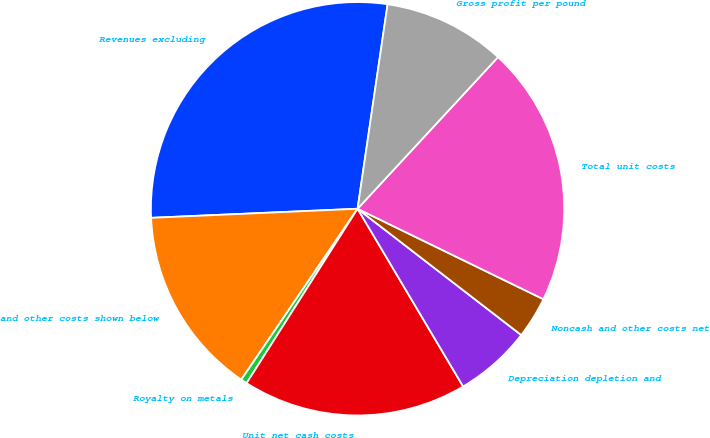<chart> <loc_0><loc_0><loc_500><loc_500><pie_chart><fcel>Revenues excluding<fcel>and other costs shown below<fcel>Royalty on metals<fcel>Unit net cash costs<fcel>Depreciation depletion and<fcel>Noncash and other costs net<fcel>Total unit costs<fcel>Gross profit per pound<nl><fcel>28.02%<fcel>14.79%<fcel>0.49%<fcel>17.55%<fcel>6.01%<fcel>3.25%<fcel>20.32%<fcel>9.57%<nl></chart> 